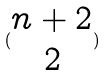Convert formula to latex. <formula><loc_0><loc_0><loc_500><loc_500>( \begin{matrix} n + 2 \\ 2 \end{matrix} )</formula> 